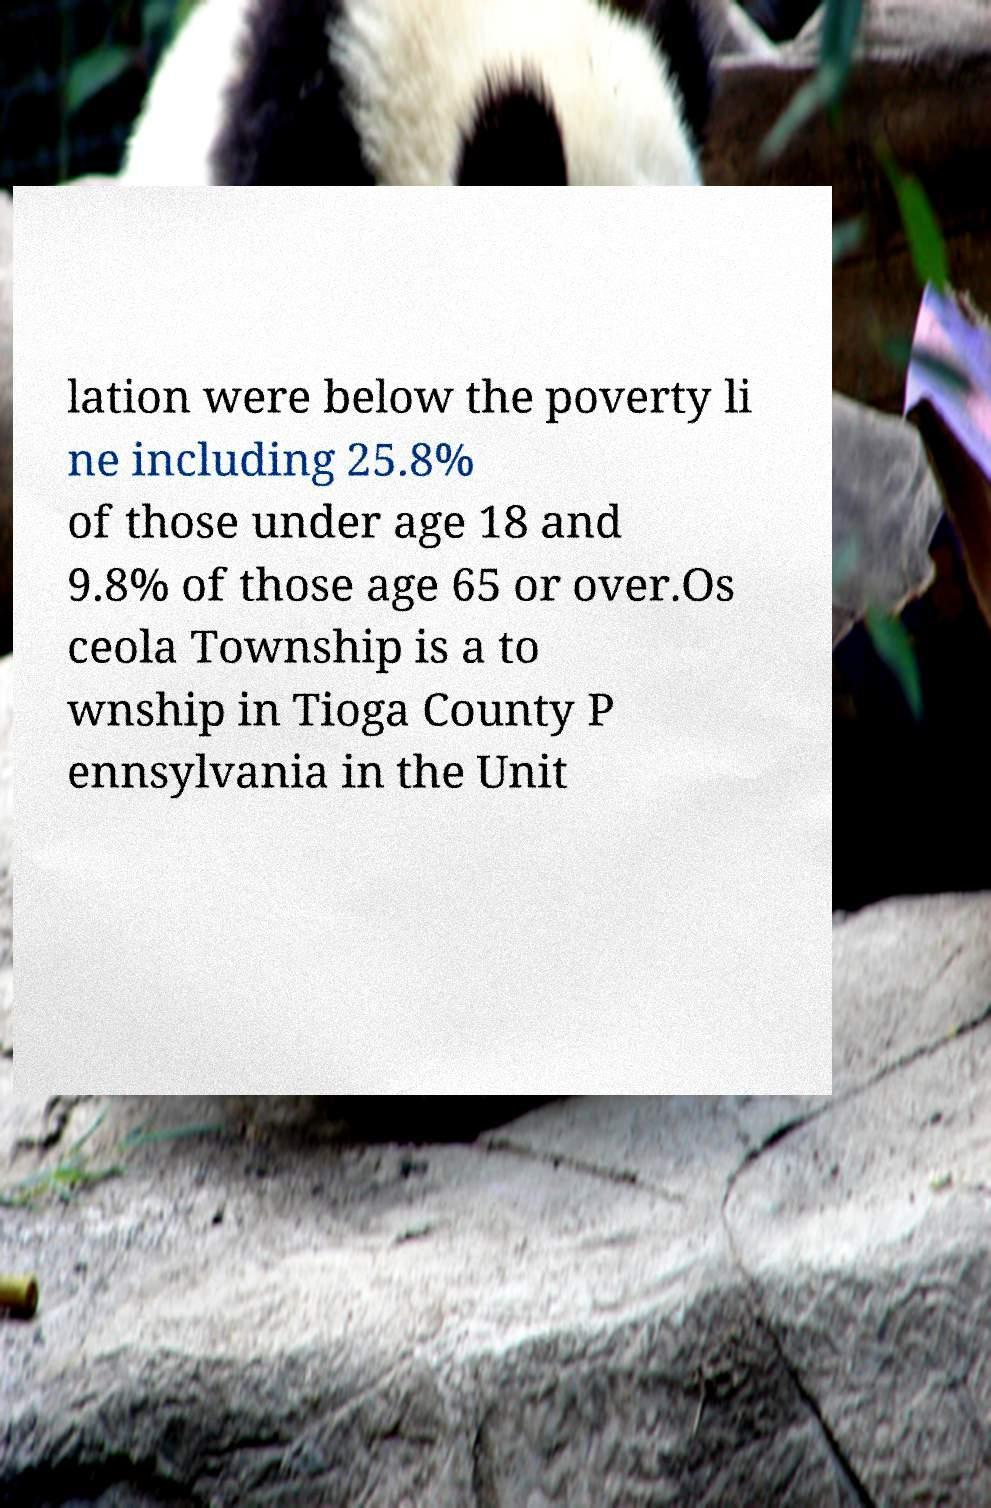Can you accurately transcribe the text from the provided image for me? lation were below the poverty li ne including 25.8% of those under age 18 and 9.8% of those age 65 or over.Os ceola Township is a to wnship in Tioga County P ennsylvania in the Unit 